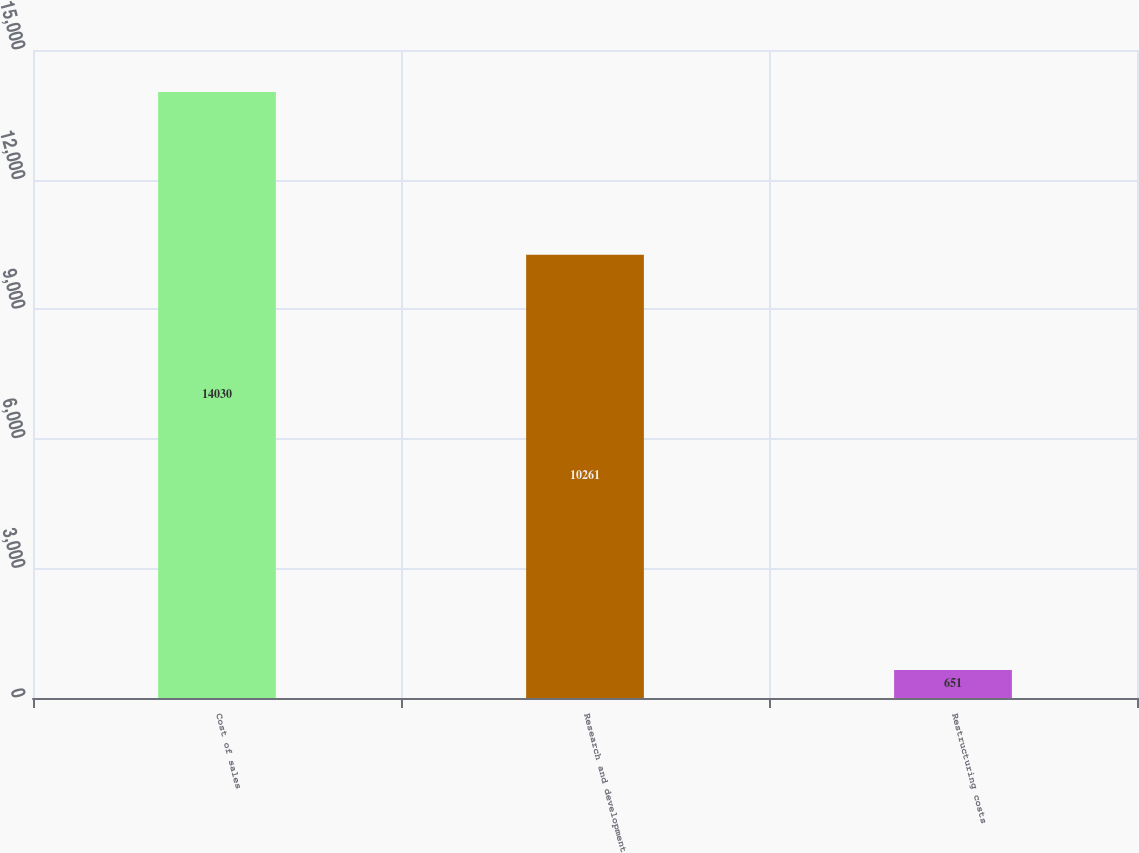<chart> <loc_0><loc_0><loc_500><loc_500><bar_chart><fcel>Cost of sales<fcel>Research and development<fcel>Restructuring costs<nl><fcel>14030<fcel>10261<fcel>651<nl></chart> 